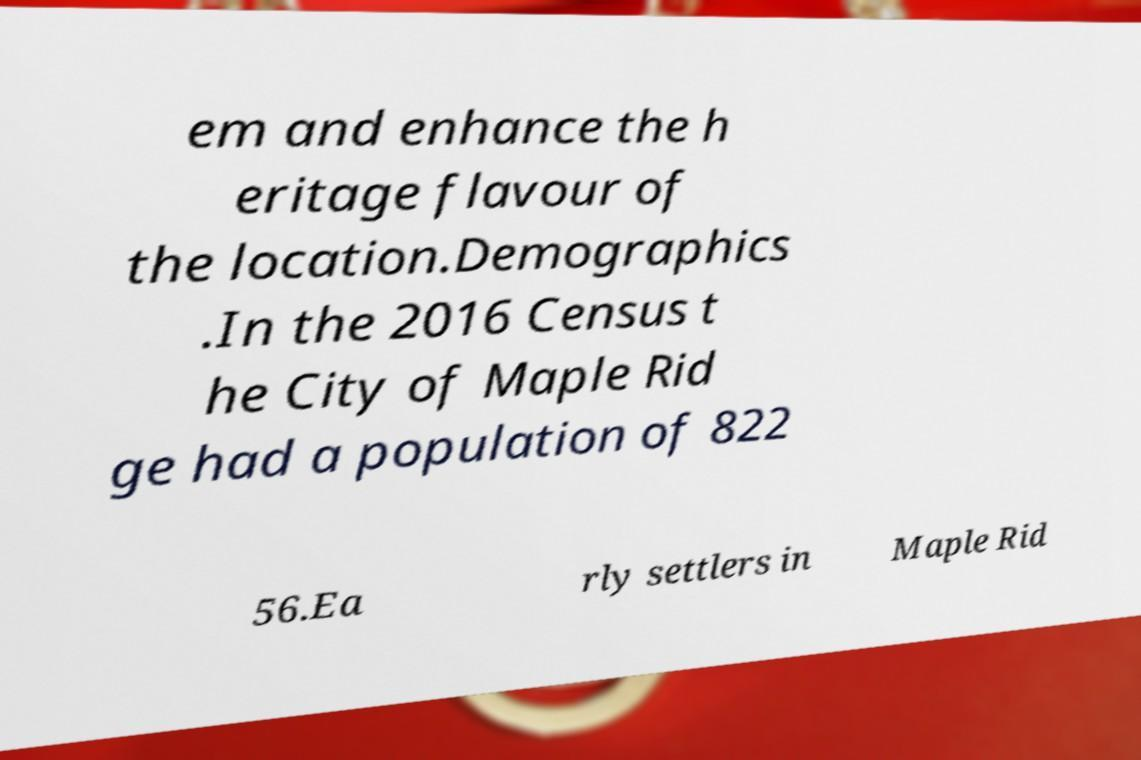Can you accurately transcribe the text from the provided image for me? em and enhance the h eritage flavour of the location.Demographics .In the 2016 Census t he City of Maple Rid ge had a population of 822 56.Ea rly settlers in Maple Rid 